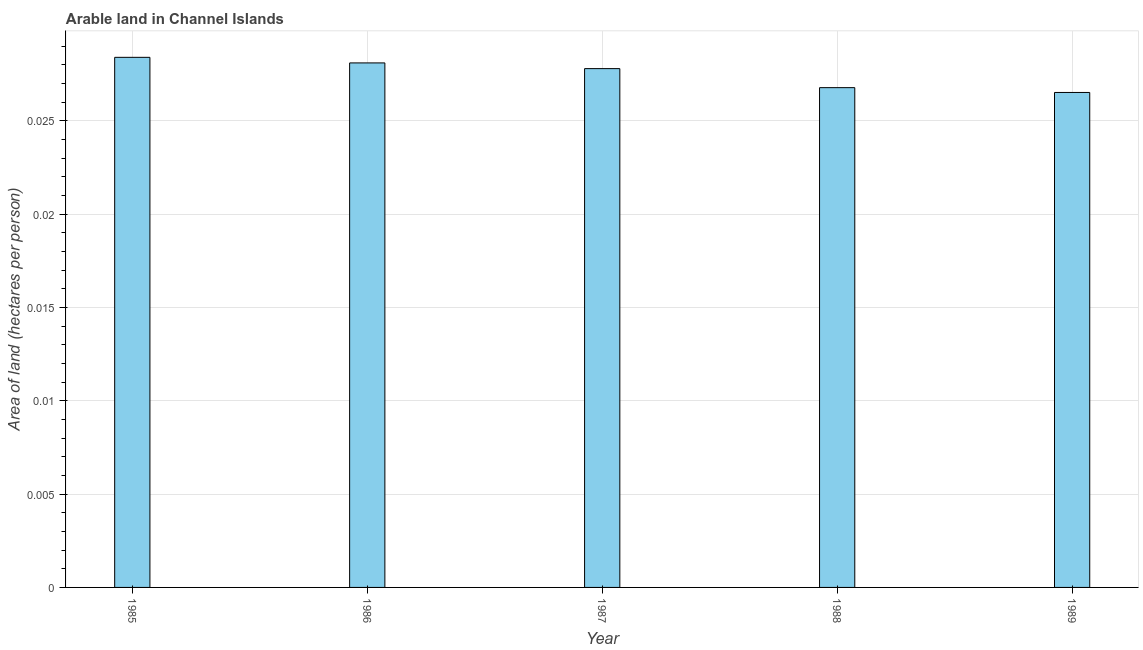Does the graph contain grids?
Your response must be concise. Yes. What is the title of the graph?
Give a very brief answer. Arable land in Channel Islands. What is the label or title of the Y-axis?
Offer a terse response. Area of land (hectares per person). What is the area of arable land in 1989?
Keep it short and to the point. 0.03. Across all years, what is the maximum area of arable land?
Give a very brief answer. 0.03. Across all years, what is the minimum area of arable land?
Give a very brief answer. 0.03. What is the sum of the area of arable land?
Your response must be concise. 0.14. What is the average area of arable land per year?
Offer a terse response. 0.03. What is the median area of arable land?
Your answer should be compact. 0.03. What is the ratio of the area of arable land in 1985 to that in 1986?
Make the answer very short. 1.01. Is the sum of the area of arable land in 1987 and 1988 greater than the maximum area of arable land across all years?
Offer a very short reply. Yes. Are all the bars in the graph horizontal?
Keep it short and to the point. No. How many years are there in the graph?
Offer a terse response. 5. What is the difference between two consecutive major ticks on the Y-axis?
Provide a short and direct response. 0.01. Are the values on the major ticks of Y-axis written in scientific E-notation?
Give a very brief answer. No. What is the Area of land (hectares per person) of 1985?
Your answer should be very brief. 0.03. What is the Area of land (hectares per person) of 1986?
Ensure brevity in your answer.  0.03. What is the Area of land (hectares per person) in 1987?
Offer a terse response. 0.03. What is the Area of land (hectares per person) of 1988?
Ensure brevity in your answer.  0.03. What is the Area of land (hectares per person) of 1989?
Ensure brevity in your answer.  0.03. What is the difference between the Area of land (hectares per person) in 1985 and 1987?
Your response must be concise. 0. What is the difference between the Area of land (hectares per person) in 1985 and 1988?
Provide a short and direct response. 0. What is the difference between the Area of land (hectares per person) in 1985 and 1989?
Your answer should be very brief. 0. What is the difference between the Area of land (hectares per person) in 1986 and 1987?
Your answer should be compact. 0. What is the difference between the Area of land (hectares per person) in 1986 and 1988?
Offer a very short reply. 0. What is the difference between the Area of land (hectares per person) in 1986 and 1989?
Give a very brief answer. 0. What is the difference between the Area of land (hectares per person) in 1987 and 1988?
Give a very brief answer. 0. What is the difference between the Area of land (hectares per person) in 1987 and 1989?
Keep it short and to the point. 0. What is the difference between the Area of land (hectares per person) in 1988 and 1989?
Offer a very short reply. 0. What is the ratio of the Area of land (hectares per person) in 1985 to that in 1986?
Ensure brevity in your answer.  1.01. What is the ratio of the Area of land (hectares per person) in 1985 to that in 1988?
Your response must be concise. 1.06. What is the ratio of the Area of land (hectares per person) in 1985 to that in 1989?
Provide a short and direct response. 1.07. What is the ratio of the Area of land (hectares per person) in 1986 to that in 1987?
Provide a short and direct response. 1.01. What is the ratio of the Area of land (hectares per person) in 1986 to that in 1988?
Give a very brief answer. 1.05. What is the ratio of the Area of land (hectares per person) in 1986 to that in 1989?
Your answer should be very brief. 1.06. What is the ratio of the Area of land (hectares per person) in 1987 to that in 1988?
Keep it short and to the point. 1.04. What is the ratio of the Area of land (hectares per person) in 1987 to that in 1989?
Your response must be concise. 1.05. 